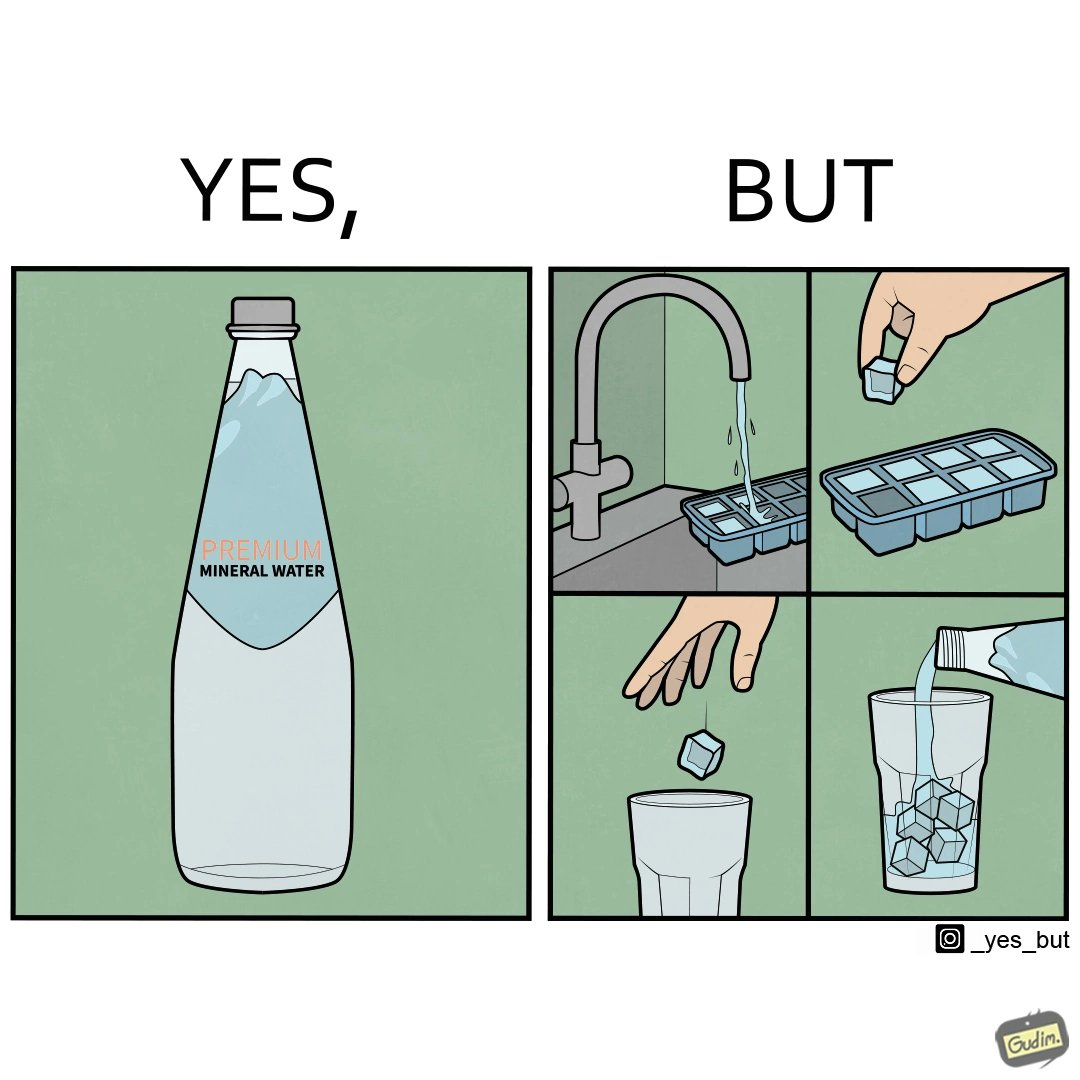Why is this image considered satirical? This image is ironical, as a bottle of mineral water is being used along with ice cubes from tap water, while the sama tap water could have been instead used. 